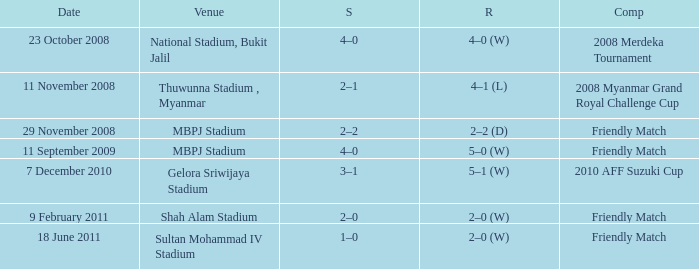What was the competition where the final score was 2-0? Friendly Match. 